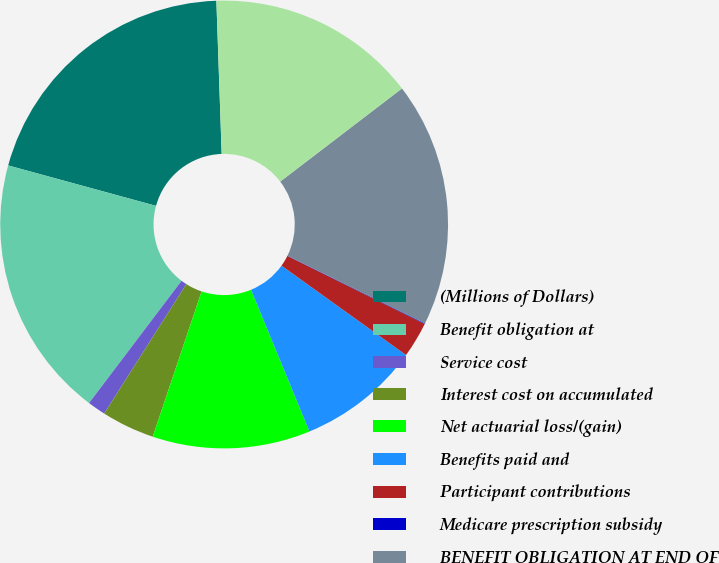Convert chart to OTSL. <chart><loc_0><loc_0><loc_500><loc_500><pie_chart><fcel>(Millions of Dollars)<fcel>Benefit obligation at<fcel>Service cost<fcel>Interest cost on accumulated<fcel>Net actuarial loss/(gain)<fcel>Benefits paid and<fcel>Participant contributions<fcel>Medicare prescription subsidy<fcel>BENEFIT OBLIGATION AT END OF<fcel>Fair value of plan assets at<nl><fcel>20.2%<fcel>18.94%<fcel>1.31%<fcel>3.83%<fcel>11.39%<fcel>8.87%<fcel>2.57%<fcel>0.05%<fcel>17.68%<fcel>15.16%<nl></chart> 